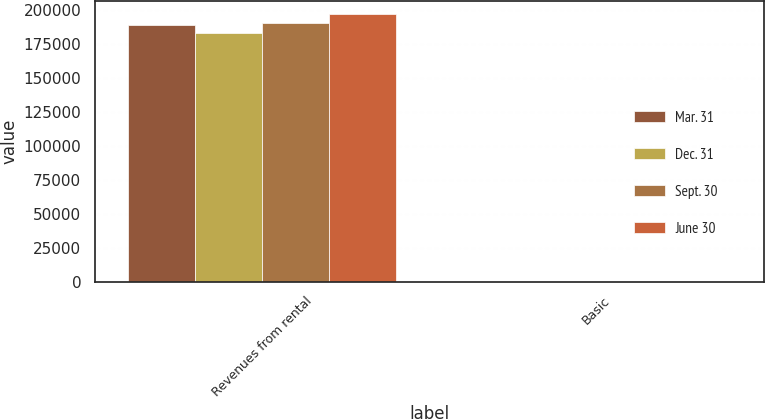<chart> <loc_0><loc_0><loc_500><loc_500><stacked_bar_chart><ecel><fcel>Revenues from rental<fcel>Basic<nl><fcel>Mar. 31<fcel>188794<fcel>0.34<nl><fcel>Dec. 31<fcel>182970<fcel>0.33<nl><fcel>Sept. 30<fcel>189951<fcel>0.38<nl><fcel>June 30<fcel>196989<fcel>0.24<nl></chart> 